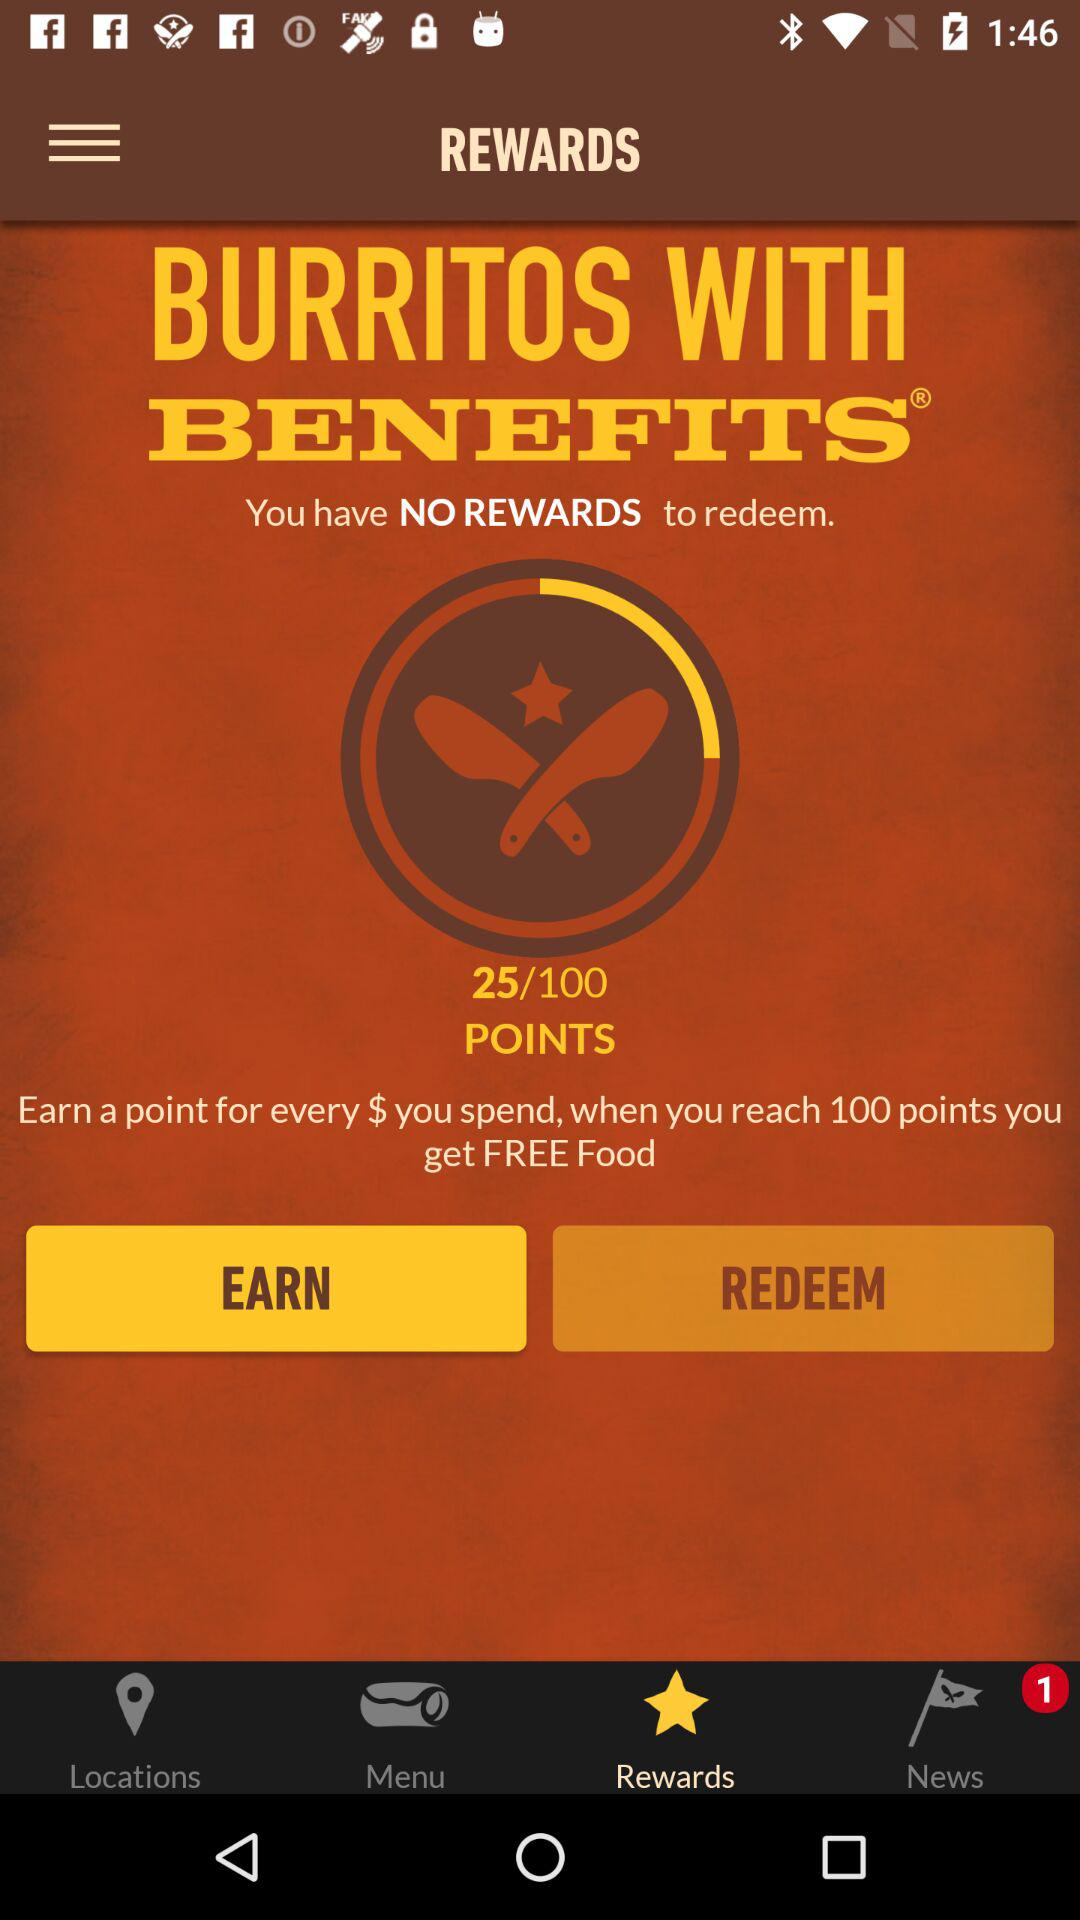Is there any news alert?
When the provided information is insufficient, respond with <no answer>. <no answer> 